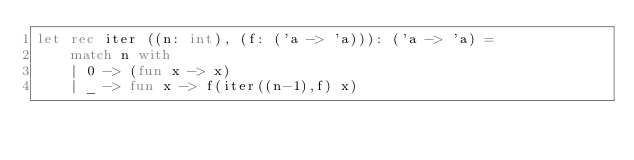<code> <loc_0><loc_0><loc_500><loc_500><_OCaml_>let rec iter ((n: int), (f: ('a -> 'a))): ('a -> 'a) = 
	match n with
	| 0 -> (fun x -> x)
	| _ -> fun x -> f(iter((n-1),f) x)</code> 